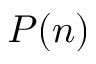Convert formula to latex. <formula><loc_0><loc_0><loc_500><loc_500>P ( n )</formula> 